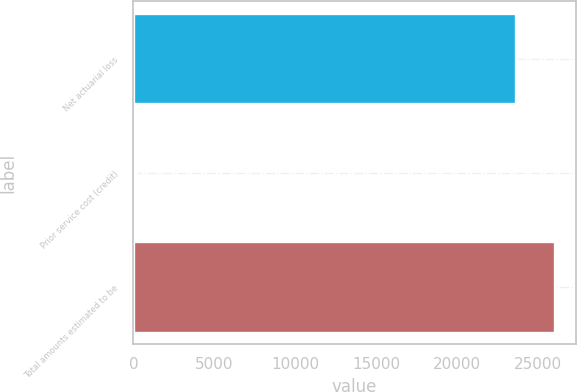Convert chart to OTSL. <chart><loc_0><loc_0><loc_500><loc_500><bar_chart><fcel>Net actuarial loss<fcel>Prior service cost (credit)<fcel>Total amounts estimated to be<nl><fcel>23638<fcel>179<fcel>26011.2<nl></chart> 